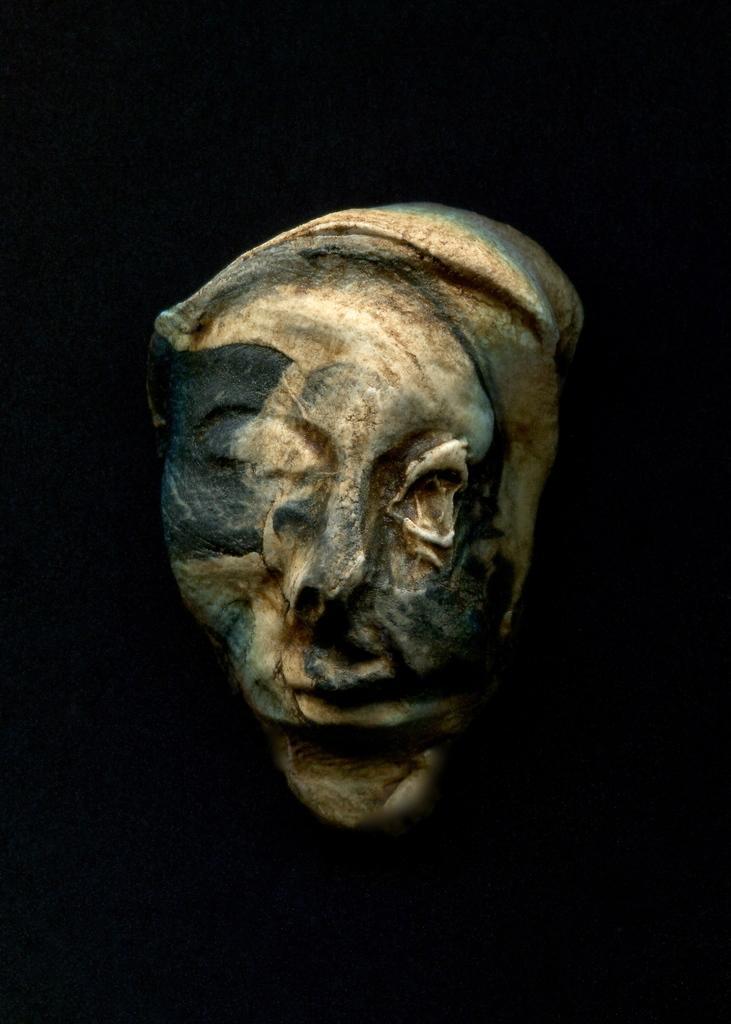Describe this image in one or two sentences. In this image we can see one sculpture and there is a black background. 